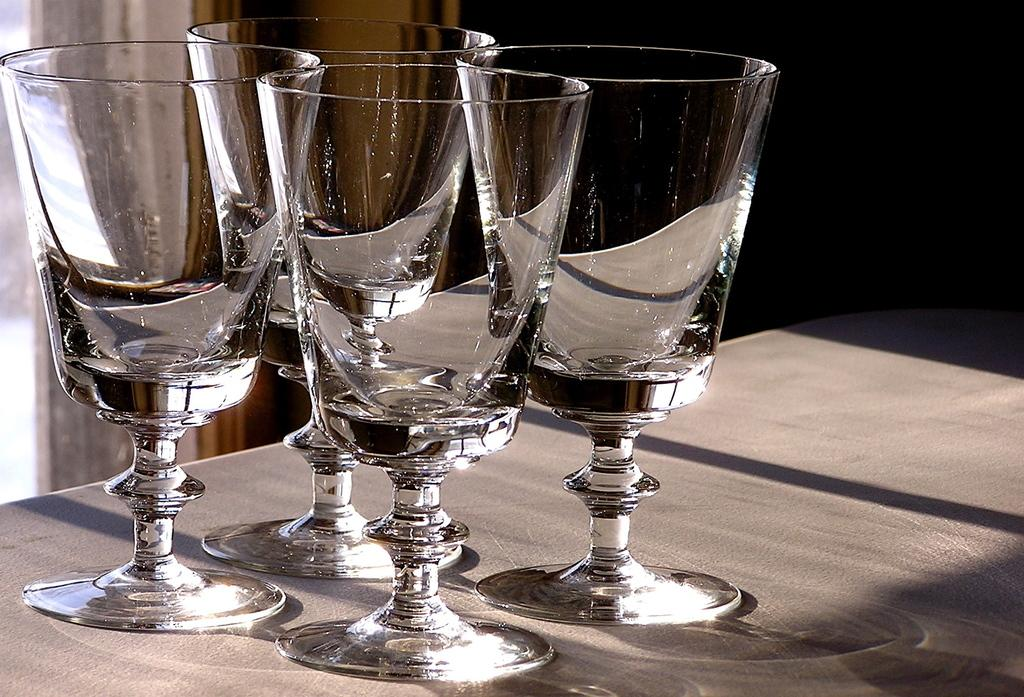How many wine glasses are visible in the image? There are four wine glasses in the image. What is the color of the surface on which the wine glasses are placed? The wine glasses are on a grey colored surface. What color is the background of the image? The background of the image is black. What type of marble is used to decorate the wine glasses in the image? There is no marble present in the image, and the wine glasses are not decorated with any marble. 